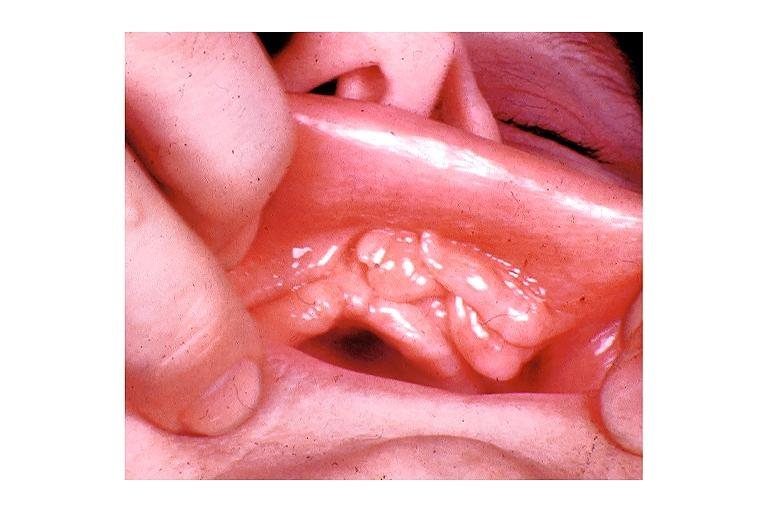s lymphoid atrophy in newborn present?
Answer the question using a single word or phrase. No 